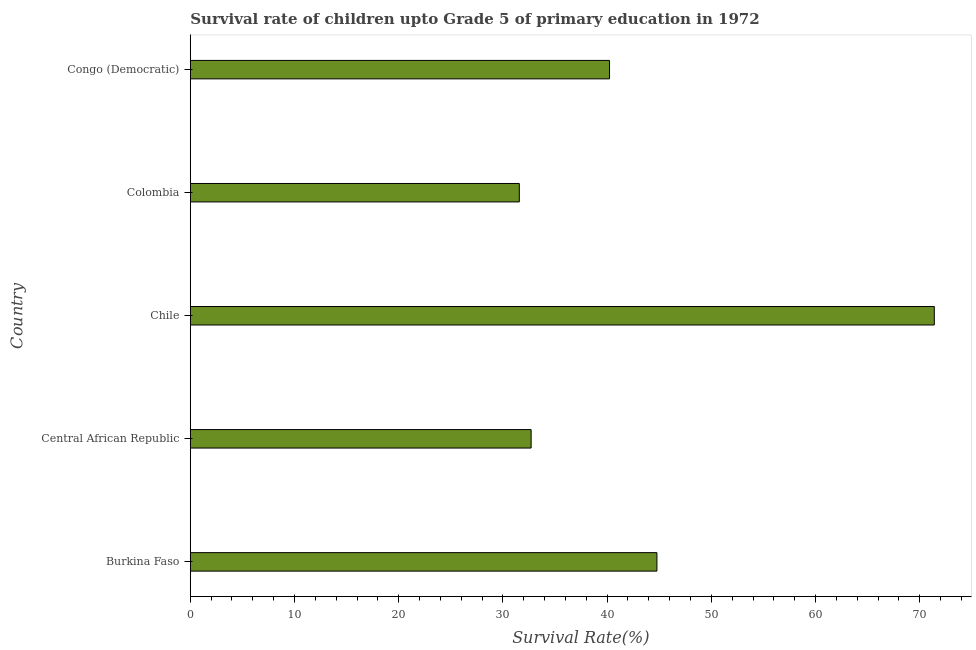Does the graph contain grids?
Keep it short and to the point. No. What is the title of the graph?
Offer a terse response. Survival rate of children upto Grade 5 of primary education in 1972 . What is the label or title of the X-axis?
Your answer should be very brief. Survival Rate(%). What is the label or title of the Y-axis?
Provide a succinct answer. Country. What is the survival rate in Congo (Democratic)?
Offer a very short reply. 40.23. Across all countries, what is the maximum survival rate?
Keep it short and to the point. 71.39. Across all countries, what is the minimum survival rate?
Give a very brief answer. 31.57. What is the sum of the survival rate?
Give a very brief answer. 220.68. What is the difference between the survival rate in Central African Republic and Congo (Democratic)?
Offer a very short reply. -7.52. What is the average survival rate per country?
Your answer should be very brief. 44.14. What is the median survival rate?
Keep it short and to the point. 40.23. What is the ratio of the survival rate in Burkina Faso to that in Central African Republic?
Your answer should be compact. 1.37. Is the difference between the survival rate in Colombia and Congo (Democratic) greater than the difference between any two countries?
Provide a succinct answer. No. What is the difference between the highest and the second highest survival rate?
Your answer should be very brief. 26.62. What is the difference between the highest and the lowest survival rate?
Give a very brief answer. 39.82. How many bars are there?
Your response must be concise. 5. How many countries are there in the graph?
Offer a very short reply. 5. What is the difference between two consecutive major ticks on the X-axis?
Keep it short and to the point. 10. What is the Survival Rate(%) of Burkina Faso?
Provide a succinct answer. 44.78. What is the Survival Rate(%) in Central African Republic?
Give a very brief answer. 32.71. What is the Survival Rate(%) in Chile?
Give a very brief answer. 71.39. What is the Survival Rate(%) in Colombia?
Your response must be concise. 31.57. What is the Survival Rate(%) of Congo (Democratic)?
Ensure brevity in your answer.  40.23. What is the difference between the Survival Rate(%) in Burkina Faso and Central African Republic?
Ensure brevity in your answer.  12.07. What is the difference between the Survival Rate(%) in Burkina Faso and Chile?
Keep it short and to the point. -26.62. What is the difference between the Survival Rate(%) in Burkina Faso and Colombia?
Offer a very short reply. 13.2. What is the difference between the Survival Rate(%) in Burkina Faso and Congo (Democratic)?
Provide a short and direct response. 4.55. What is the difference between the Survival Rate(%) in Central African Republic and Chile?
Provide a short and direct response. -38.69. What is the difference between the Survival Rate(%) in Central African Republic and Colombia?
Keep it short and to the point. 1.13. What is the difference between the Survival Rate(%) in Central African Republic and Congo (Democratic)?
Provide a succinct answer. -7.52. What is the difference between the Survival Rate(%) in Chile and Colombia?
Give a very brief answer. 39.82. What is the difference between the Survival Rate(%) in Chile and Congo (Democratic)?
Make the answer very short. 31.16. What is the difference between the Survival Rate(%) in Colombia and Congo (Democratic)?
Keep it short and to the point. -8.66. What is the ratio of the Survival Rate(%) in Burkina Faso to that in Central African Republic?
Give a very brief answer. 1.37. What is the ratio of the Survival Rate(%) in Burkina Faso to that in Chile?
Offer a terse response. 0.63. What is the ratio of the Survival Rate(%) in Burkina Faso to that in Colombia?
Your response must be concise. 1.42. What is the ratio of the Survival Rate(%) in Burkina Faso to that in Congo (Democratic)?
Provide a succinct answer. 1.11. What is the ratio of the Survival Rate(%) in Central African Republic to that in Chile?
Make the answer very short. 0.46. What is the ratio of the Survival Rate(%) in Central African Republic to that in Colombia?
Your response must be concise. 1.04. What is the ratio of the Survival Rate(%) in Central African Republic to that in Congo (Democratic)?
Ensure brevity in your answer.  0.81. What is the ratio of the Survival Rate(%) in Chile to that in Colombia?
Ensure brevity in your answer.  2.26. What is the ratio of the Survival Rate(%) in Chile to that in Congo (Democratic)?
Your response must be concise. 1.77. What is the ratio of the Survival Rate(%) in Colombia to that in Congo (Democratic)?
Your answer should be compact. 0.79. 